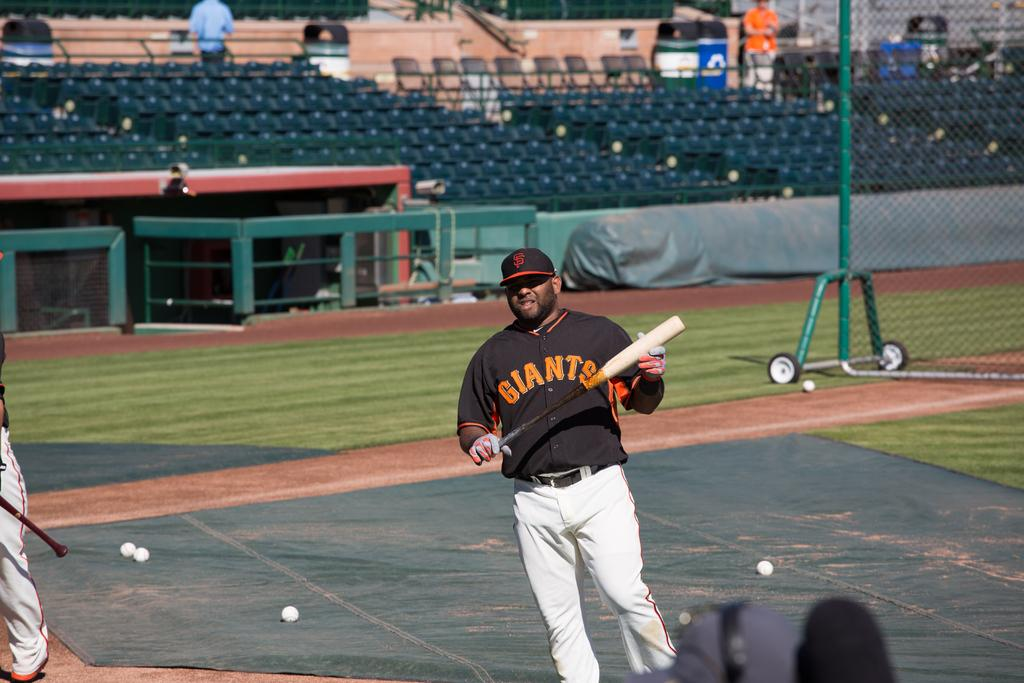<image>
Summarize the visual content of the image. A player for the Giants holds a bat in his hand 